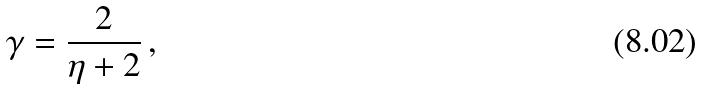<formula> <loc_0><loc_0><loc_500><loc_500>\gamma = \frac { 2 } { \eta + 2 } \, ,</formula> 